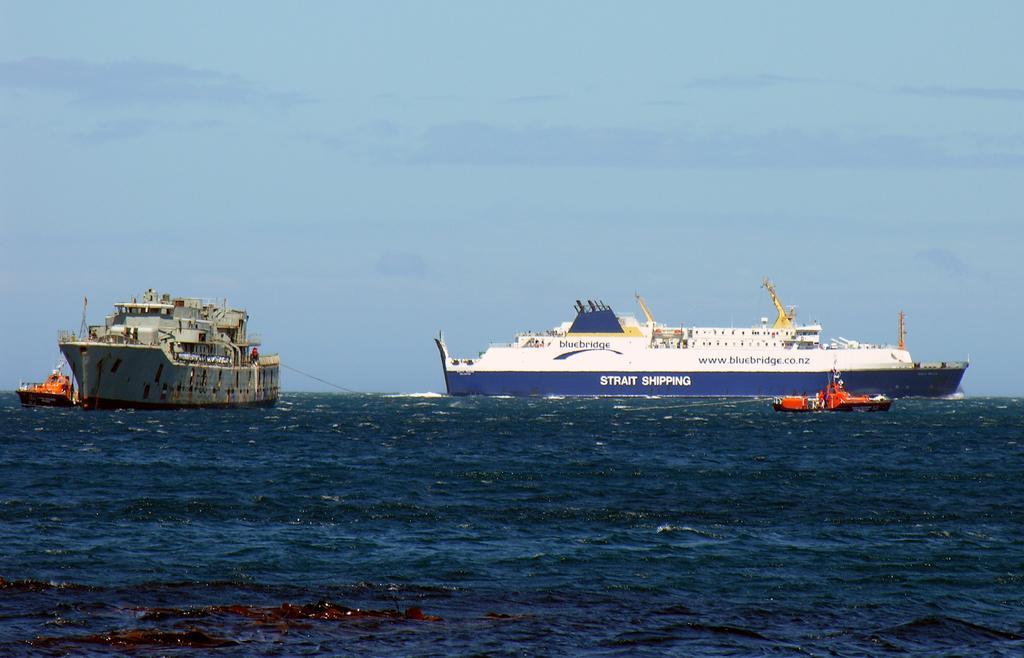Please provide a concise description of this image. In this picture we can see few ships on the water. 